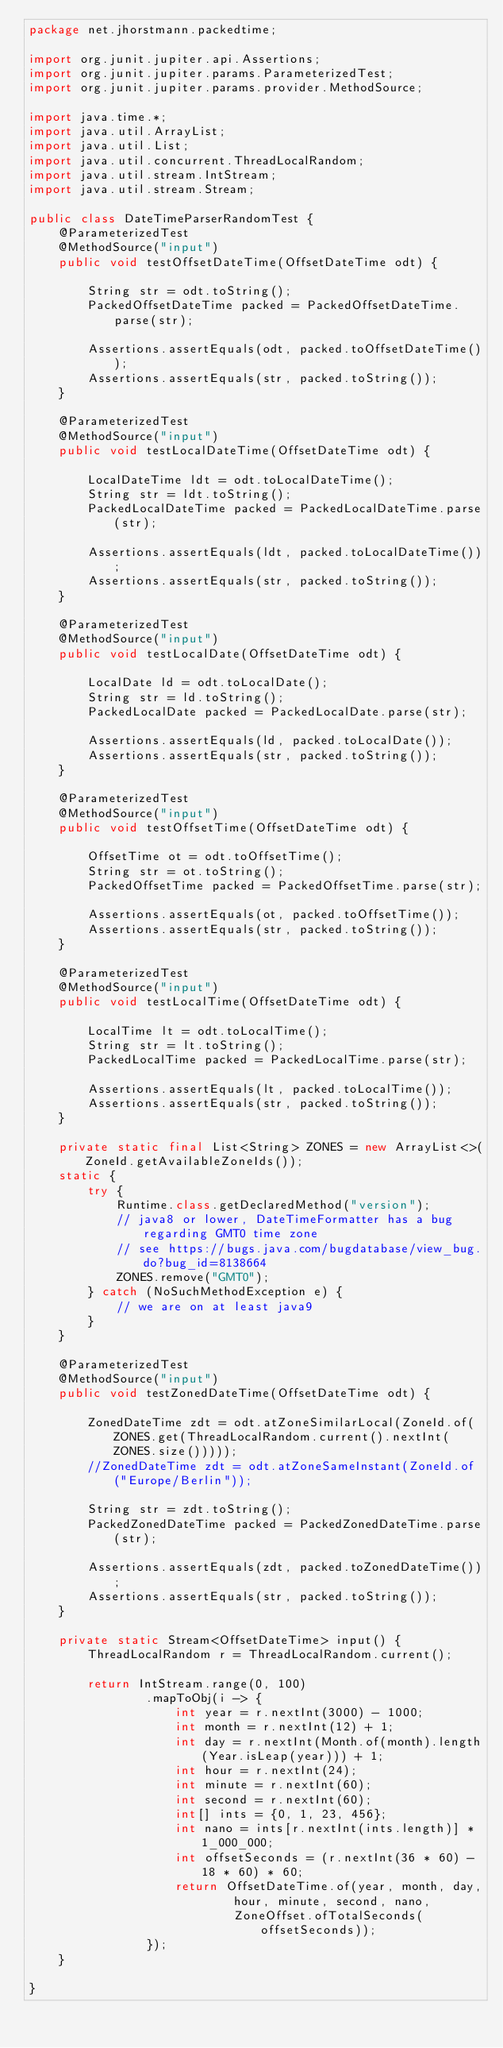<code> <loc_0><loc_0><loc_500><loc_500><_Java_>package net.jhorstmann.packedtime;

import org.junit.jupiter.api.Assertions;
import org.junit.jupiter.params.ParameterizedTest;
import org.junit.jupiter.params.provider.MethodSource;

import java.time.*;
import java.util.ArrayList;
import java.util.List;
import java.util.concurrent.ThreadLocalRandom;
import java.util.stream.IntStream;
import java.util.stream.Stream;

public class DateTimeParserRandomTest {
    @ParameterizedTest
    @MethodSource("input")
    public void testOffsetDateTime(OffsetDateTime odt) {

        String str = odt.toString();
        PackedOffsetDateTime packed = PackedOffsetDateTime.parse(str);

        Assertions.assertEquals(odt, packed.toOffsetDateTime());
        Assertions.assertEquals(str, packed.toString());
    }

    @ParameterizedTest
    @MethodSource("input")
    public void testLocalDateTime(OffsetDateTime odt) {

        LocalDateTime ldt = odt.toLocalDateTime();
        String str = ldt.toString();
        PackedLocalDateTime packed = PackedLocalDateTime.parse(str);

        Assertions.assertEquals(ldt, packed.toLocalDateTime());
        Assertions.assertEquals(str, packed.toString());
    }

    @ParameterizedTest
    @MethodSource("input")
    public void testLocalDate(OffsetDateTime odt) {

        LocalDate ld = odt.toLocalDate();
        String str = ld.toString();
        PackedLocalDate packed = PackedLocalDate.parse(str);

        Assertions.assertEquals(ld, packed.toLocalDate());
        Assertions.assertEquals(str, packed.toString());
    }

    @ParameterizedTest
    @MethodSource("input")
    public void testOffsetTime(OffsetDateTime odt) {

        OffsetTime ot = odt.toOffsetTime();
        String str = ot.toString();
        PackedOffsetTime packed = PackedOffsetTime.parse(str);

        Assertions.assertEquals(ot, packed.toOffsetTime());
        Assertions.assertEquals(str, packed.toString());
    }

    @ParameterizedTest
    @MethodSource("input")
    public void testLocalTime(OffsetDateTime odt) {

        LocalTime lt = odt.toLocalTime();
        String str = lt.toString();
        PackedLocalTime packed = PackedLocalTime.parse(str);

        Assertions.assertEquals(lt, packed.toLocalTime());
        Assertions.assertEquals(str, packed.toString());
    }

    private static final List<String> ZONES = new ArrayList<>(ZoneId.getAvailableZoneIds());
    static {
        try {
            Runtime.class.getDeclaredMethod("version");
            // java8 or lower, DateTimeFormatter has a bug regarding GMT0 time zone
            // see https://bugs.java.com/bugdatabase/view_bug.do?bug_id=8138664
            ZONES.remove("GMT0");
        } catch (NoSuchMethodException e) {
            // we are on at least java9
        }
    }

    @ParameterizedTest
    @MethodSource("input")
    public void testZonedDateTime(OffsetDateTime odt) {

        ZonedDateTime zdt = odt.atZoneSimilarLocal(ZoneId.of(ZONES.get(ThreadLocalRandom.current().nextInt(ZONES.size()))));
        //ZonedDateTime zdt = odt.atZoneSameInstant(ZoneId.of("Europe/Berlin"));

        String str = zdt.toString();
        PackedZonedDateTime packed = PackedZonedDateTime.parse(str);

        Assertions.assertEquals(zdt, packed.toZonedDateTime());
        Assertions.assertEquals(str, packed.toString());
    }

    private static Stream<OffsetDateTime> input() {
        ThreadLocalRandom r = ThreadLocalRandom.current();

        return IntStream.range(0, 100)
                .mapToObj(i -> {
                    int year = r.nextInt(3000) - 1000;
                    int month = r.nextInt(12) + 1;
                    int day = r.nextInt(Month.of(month).length(Year.isLeap(year))) + 1;
                    int hour = r.nextInt(24);
                    int minute = r.nextInt(60);
                    int second = r.nextInt(60);
                    int[] ints = {0, 1, 23, 456};
                    int nano = ints[r.nextInt(ints.length)] * 1_000_000;
                    int offsetSeconds = (r.nextInt(36 * 60) - 18 * 60) * 60;
                    return OffsetDateTime.of(year, month, day,
                            hour, minute, second, nano,
                            ZoneOffset.ofTotalSeconds(offsetSeconds));
                });
    }

}
</code> 